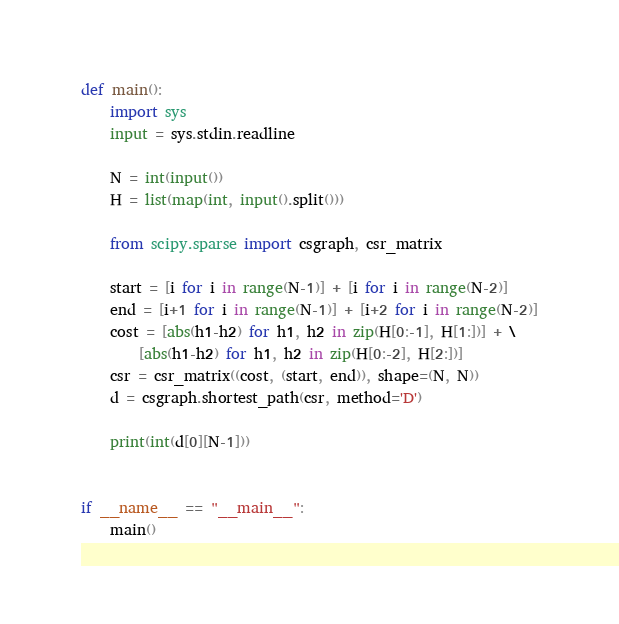<code> <loc_0><loc_0><loc_500><loc_500><_Python_>def main():
    import sys
    input = sys.stdin.readline

    N = int(input())
    H = list(map(int, input().split()))

    from scipy.sparse import csgraph, csr_matrix

    start = [i for i in range(N-1)] + [i for i in range(N-2)]
    end = [i+1 for i in range(N-1)] + [i+2 for i in range(N-2)]
    cost = [abs(h1-h2) for h1, h2 in zip(H[0:-1], H[1:])] + \
        [abs(h1-h2) for h1, h2 in zip(H[0:-2], H[2:])]
    csr = csr_matrix((cost, (start, end)), shape=(N, N))
    d = csgraph.shortest_path(csr, method='D')

    print(int(d[0][N-1]))


if __name__ == "__main__":
    main()
</code> 